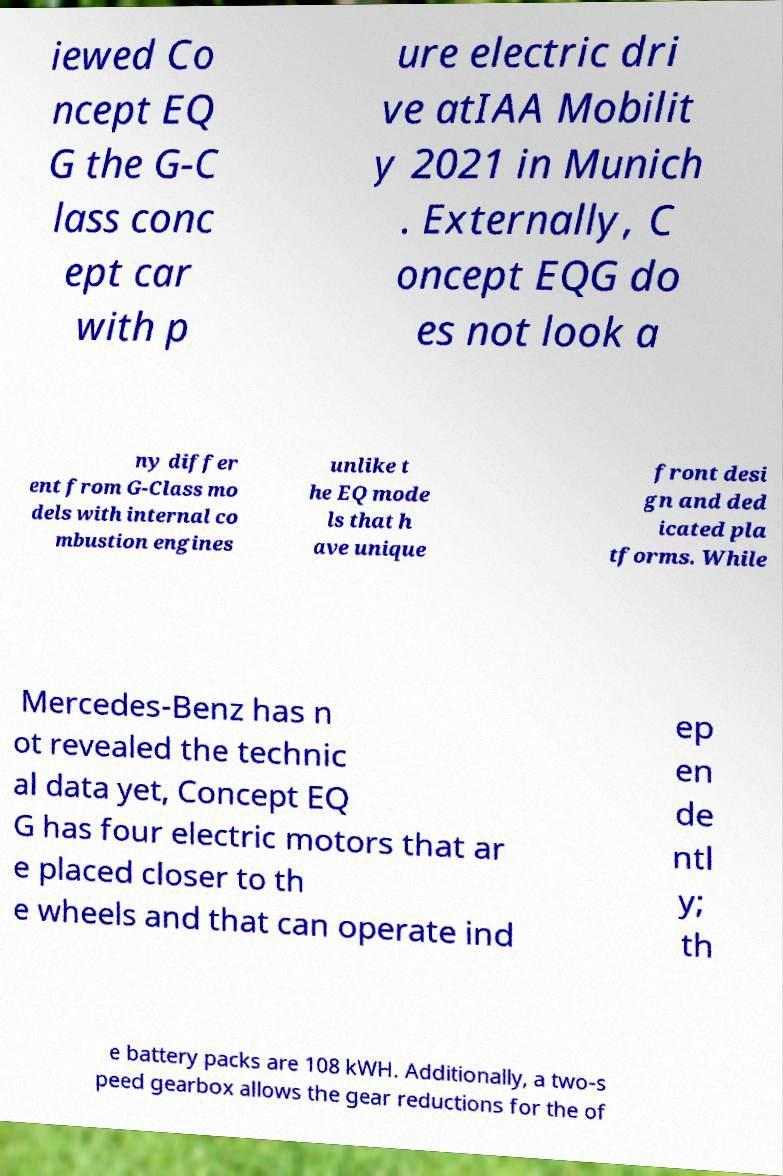There's text embedded in this image that I need extracted. Can you transcribe it verbatim? iewed Co ncept EQ G the G-C lass conc ept car with p ure electric dri ve atIAA Mobilit y 2021 in Munich . Externally, C oncept EQG do es not look a ny differ ent from G-Class mo dels with internal co mbustion engines unlike t he EQ mode ls that h ave unique front desi gn and ded icated pla tforms. While Mercedes-Benz has n ot revealed the technic al data yet, Concept EQ G has four electric motors that ar e placed closer to th e wheels and that can operate ind ep en de ntl y; th e battery packs are 108 kWH. Additionally, a two-s peed gearbox allows the gear reductions for the of 